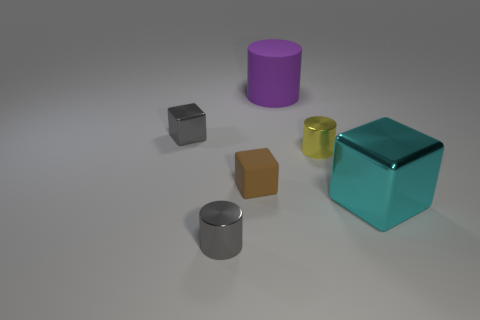Is there any other thing of the same color as the big metallic thing?
Ensure brevity in your answer.  No. What shape is the small shiny object that is the same color as the small metal block?
Your answer should be compact. Cylinder. There is a metallic cube to the right of the matte cylinder; how big is it?
Give a very brief answer. Large. The yellow thing that is the same size as the matte cube is what shape?
Your answer should be very brief. Cylinder. Is the material of the tiny object that is to the right of the big purple cylinder the same as the big thing that is left of the large cyan shiny thing?
Your answer should be very brief. No. There is a tiny cube that is left of the small gray metallic thing in front of the big cyan metallic cube; what is it made of?
Ensure brevity in your answer.  Metal. What size is the rubber object that is behind the gray shiny thing behind the gray thing that is in front of the large cyan thing?
Your response must be concise. Large. Is the size of the purple object the same as the gray metallic cylinder?
Offer a very short reply. No. Do the big thing that is right of the purple matte cylinder and the small metal object that is in front of the cyan thing have the same shape?
Give a very brief answer. No. There is a gray object to the right of the tiny gray block; is there a metal thing that is to the left of it?
Ensure brevity in your answer.  Yes. 